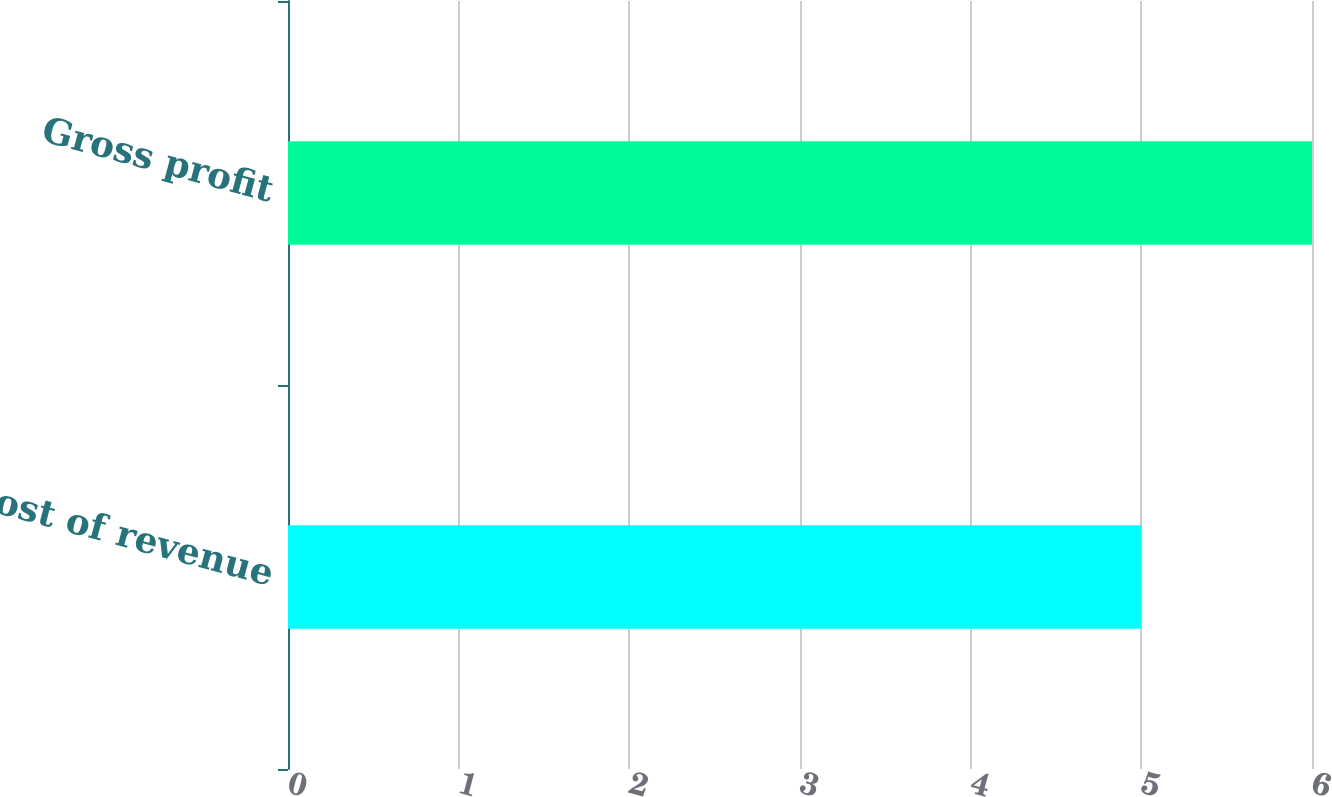Convert chart. <chart><loc_0><loc_0><loc_500><loc_500><bar_chart><fcel>Cost of revenue<fcel>Gross profit<nl><fcel>5<fcel>6<nl></chart> 